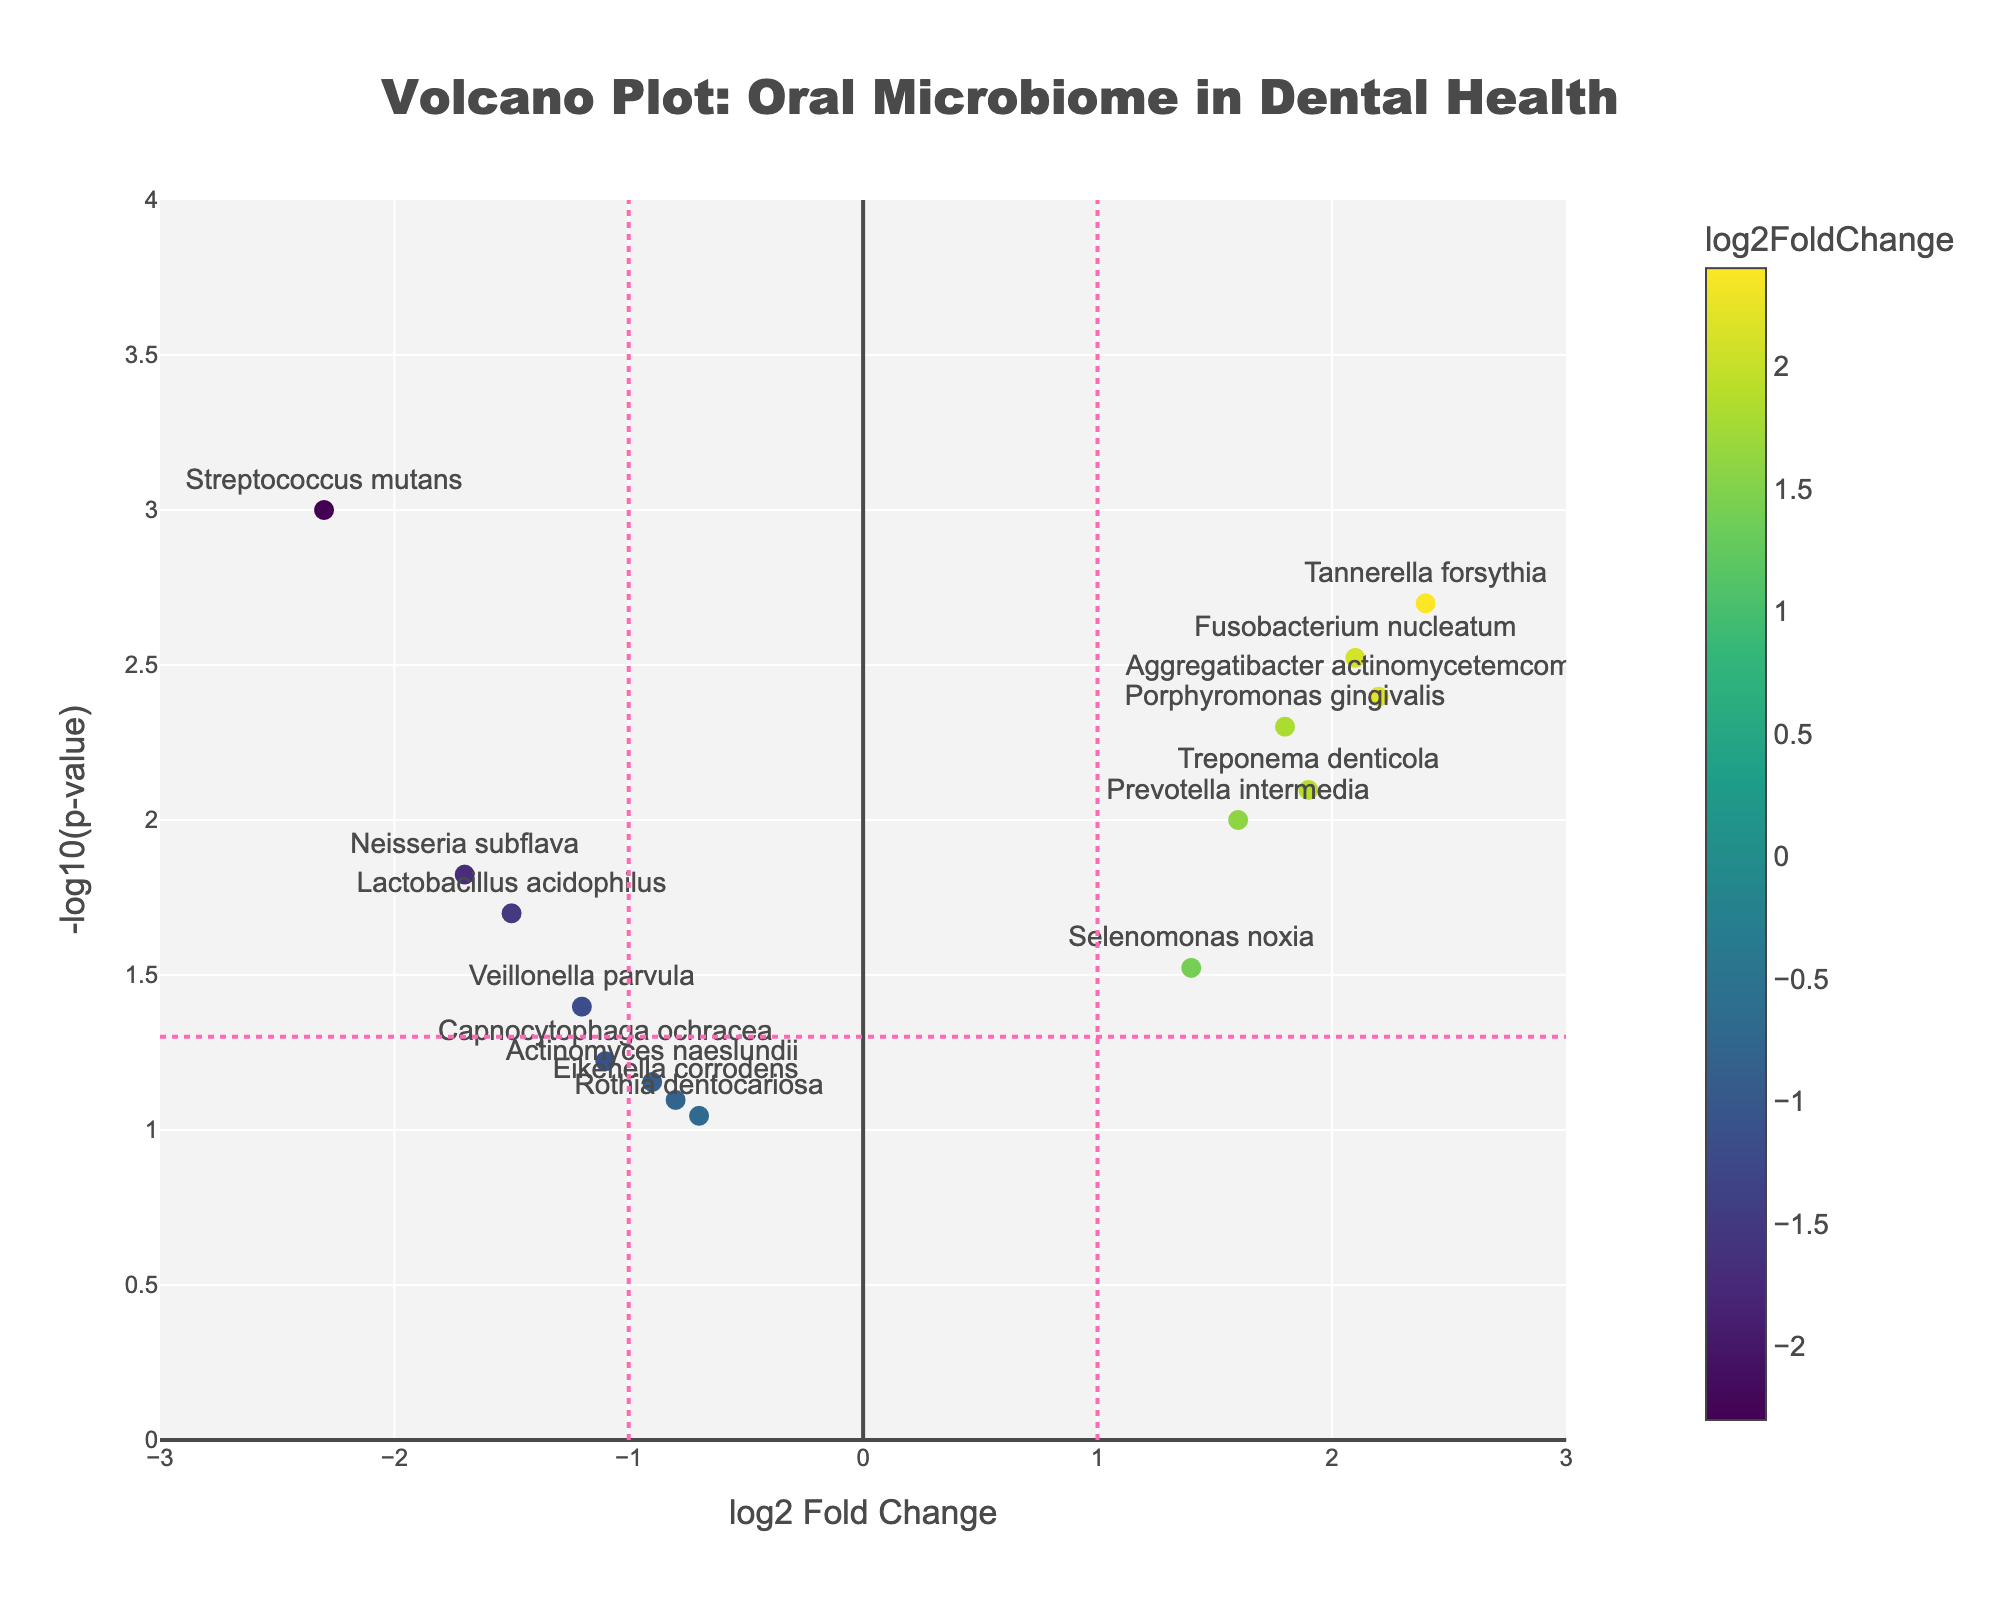What is the title of the figure? The title is typically positioned at the top center of the figure and is given in a large, bold font for visibility. By looking at the mentioned figure, you can read the title as "Volcano Plot: Oral Microbiome in Dental Health".
Answer: Volcano Plot: Oral Microbiome in Dental Health What do the x-axis and y-axis represent in the figure? The x-axis represents the log2 Fold Change, and the y-axis represents the -log10(p-value) as deduced from the axis titles mentioned in the figure.
Answer: log2 Fold Change and -log10(p-value) Which color scale is used for the marker colors, and what does it represent? The color scale mentioned is 'Viridis', which helps to differentiate data points based on their log2 Fold Change values, with a color bar indicating the gradient.
Answer: Viridis, represents log2 Fold Change How many genes have a log2 Fold Change greater than 1 and a -log10(p-value) greater than -log10(0.05)? By inspecting the figure, count the number of data points located in the top-right quadrant demarcated by the log2 Fold Change of 1 and -log10(p-value) of -log10(0.05). There are 4 such genes.
Answer: 4 Which gene has the highest log2 Fold Change, and what is its -log10(p-value)? The highest log2 Fold Change can be identified by looking at the farthest point on the x-axis on the positive side. "Tannerella forsythia" has the highest log2 Fold Change of 2.4, and checking the same point on the y-axis, its -log10(p-value) is approximately 2.7.
Answer: Tannerella forsythia, 2.4, 2.7 Which gene has the lowest p-value, and what are its log2 Fold Change and -log10(p-value)? The lowest p-value corresponds to the highest -log10(p-value). The gene "Streptococcus mutans" has the smallest p-value with a -log10(p-value) of approximately 3.0, and its log2 Fold Change is -2.3.
Answer: Streptococcus mutans, -2.3, 3.0 Are there any genes that do not meet the significance threshold of p-value < 0.05? To determine this, find gene data points that are below the horizontal threshold line of -log10(0.05), which is approximately 1.3. By referring to the figure, there are genes like Actinomyces naeslundii, Rothia dentocariosa, Capnocytophaga ochracea, and Eikenella corrodens, which lie below this line.
Answer: Yes, Actinomyces naeslundii, Rothia dentocariosa, Capnocytophaga ochracea, Eikenella corrodens How many genes have a negative log2 Fold Change and a p-value less than 0.05? Check the figure for data points on the left of the vertical threshold line at log2 Fold Change = -1 that are above the horizontal threshold line representing -log10(0.05). There are 4 such genes: Streptococcus mutans, Lactobacillus acidophilus, Veillonella parvula, and Neisseria subflava.
Answer: 4 Which gene has the smallest log2 Fold Change that is still significant (p-value < 0.05)? The smallest log2 Fold Change with a significant p-value can be identified by looking at the data point with the most negative x-axis value (leftmost) that is still above the -log10(0.05) threshold. "Streptococcus mutans" with -2.3 log2 Fold Change meets this criterion.
Answer: Streptococcus mutans, -2.3 